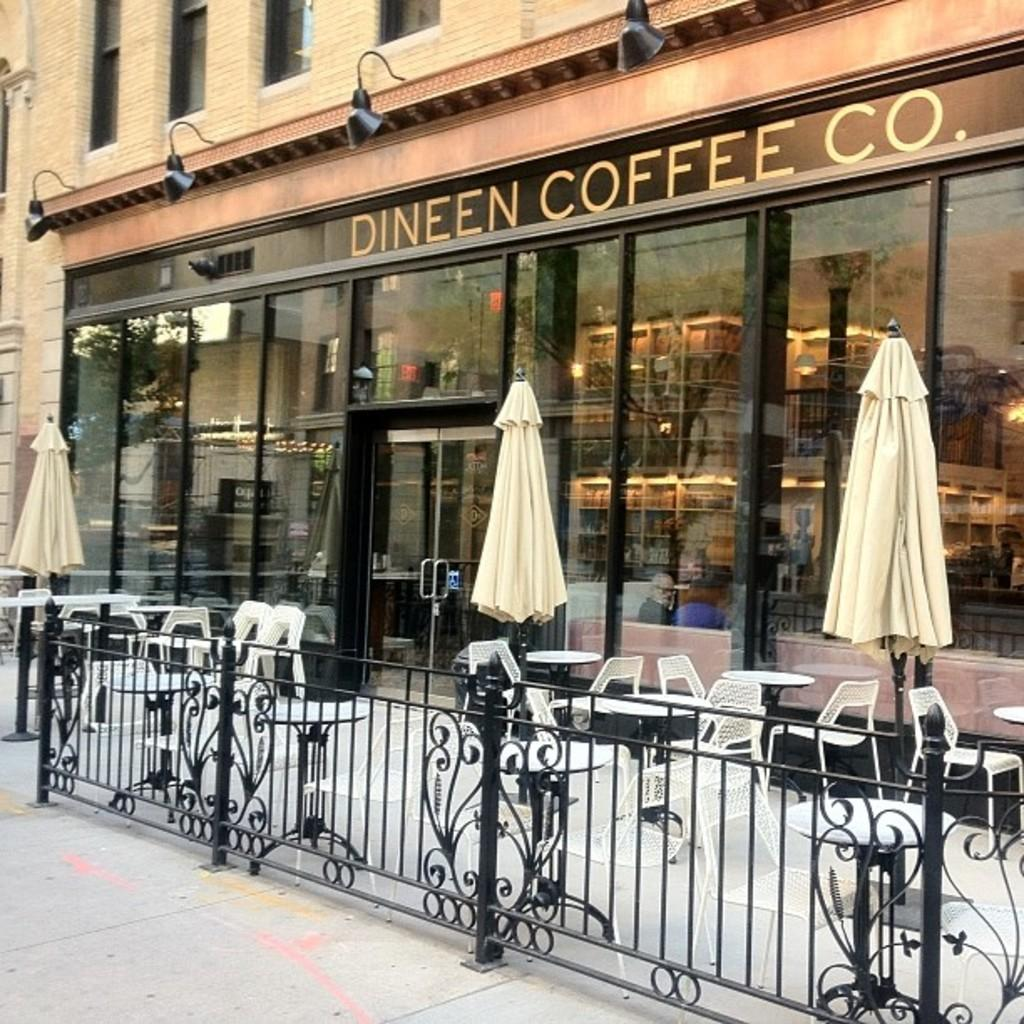What is the color of the fence in the image? The fence in the image is black. What is the color of the chairs in the image? The chairs in the image are white. What type of establishment can be seen in the image? There is a shop in the image. What type of structure is present in the image? There is a building in the image. What type of knife is being used to prepare a meal in the image? There is no knife or meal preparation visible in the image. 